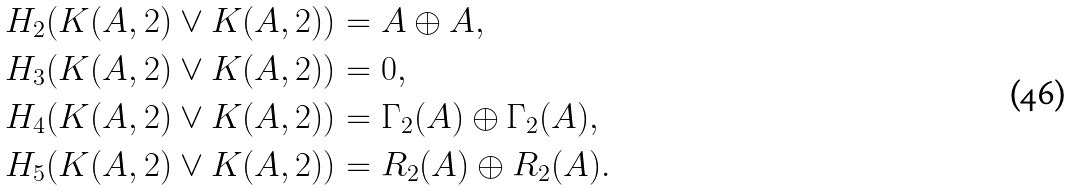Convert formula to latex. <formula><loc_0><loc_0><loc_500><loc_500>& H _ { 2 } ( K ( A , 2 ) \vee K ( A , 2 ) ) = A \oplus A , \\ & H _ { 3 } ( K ( A , 2 ) \vee K ( A , 2 ) ) = 0 , \\ & H _ { 4 } ( K ( A , 2 ) \vee K ( A , 2 ) ) = \Gamma _ { 2 } ( A ) \oplus \Gamma _ { 2 } ( A ) , \\ & H _ { 5 } ( K ( A , 2 ) \vee K ( A , 2 ) ) = R _ { 2 } ( A ) \oplus R _ { 2 } ( A ) . \\</formula> 